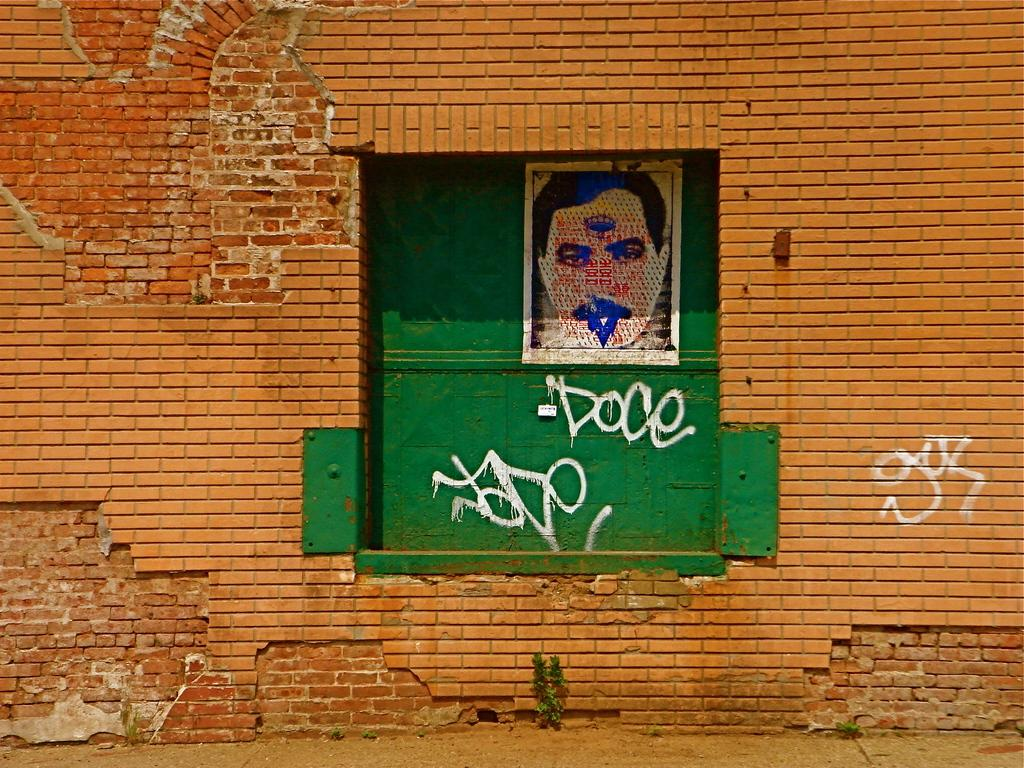What type of structure is visible in the image? There is a brick wall in the image. Are there any openings or features on the brick wall? Yes, there is a window on the brick wall. What can be seen through the window? The window has an image of a person on it. What type of zebra can be seen standing in line with the person in the image? There is no zebra present in the image. 